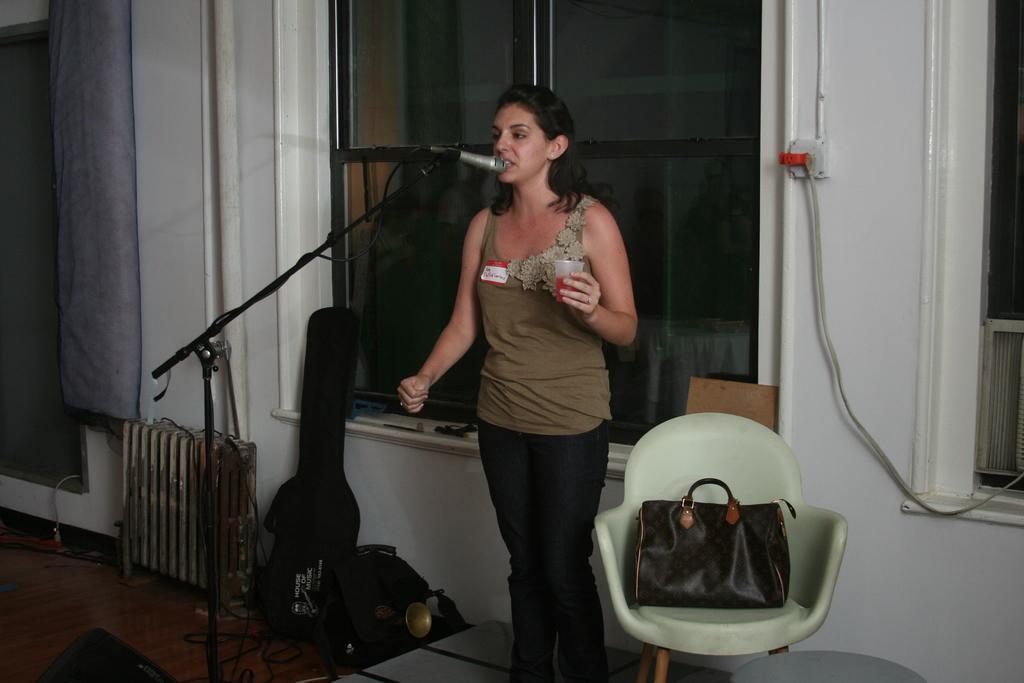Can you describe this image briefly? This woman is singing in-front of mic and holding glass. On this chair there is a bag. On floor there are cables and bags. This is window. 